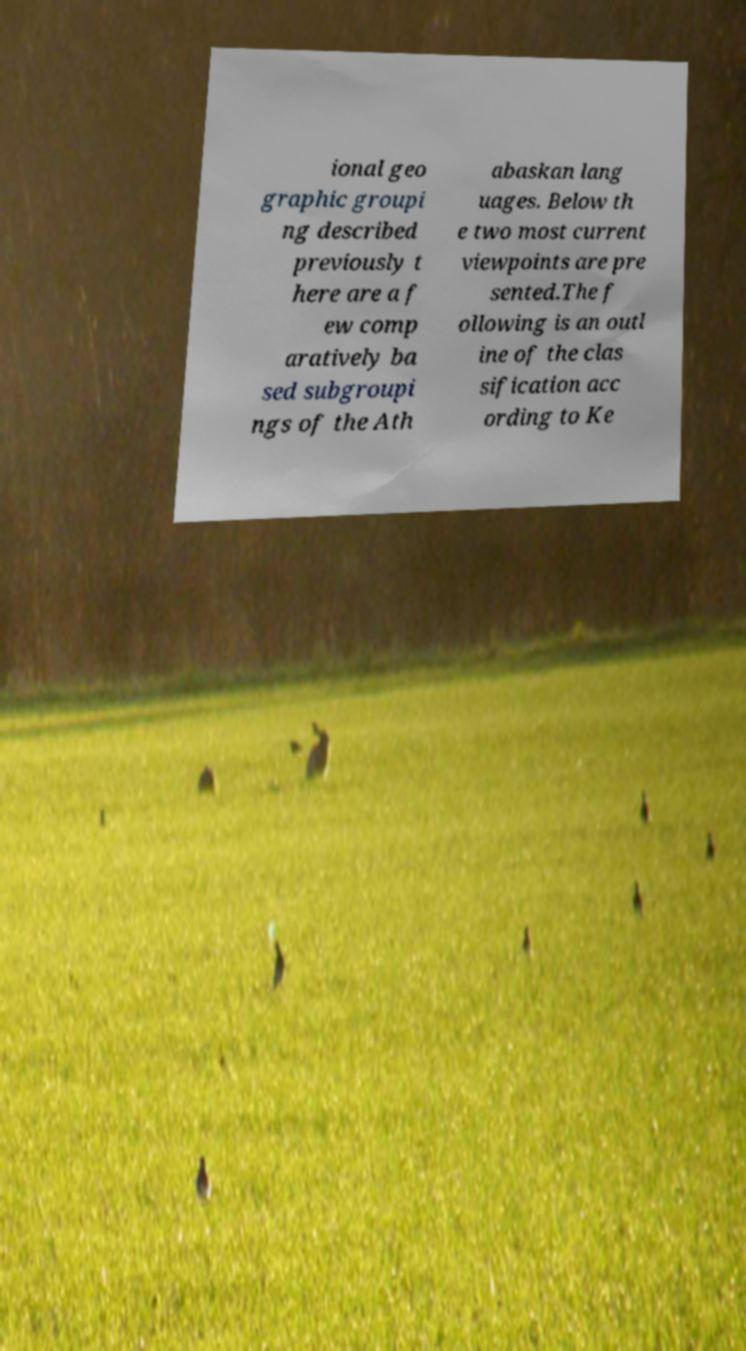For documentation purposes, I need the text within this image transcribed. Could you provide that? ional geo graphic groupi ng described previously t here are a f ew comp aratively ba sed subgroupi ngs of the Ath abaskan lang uages. Below th e two most current viewpoints are pre sented.The f ollowing is an outl ine of the clas sification acc ording to Ke 